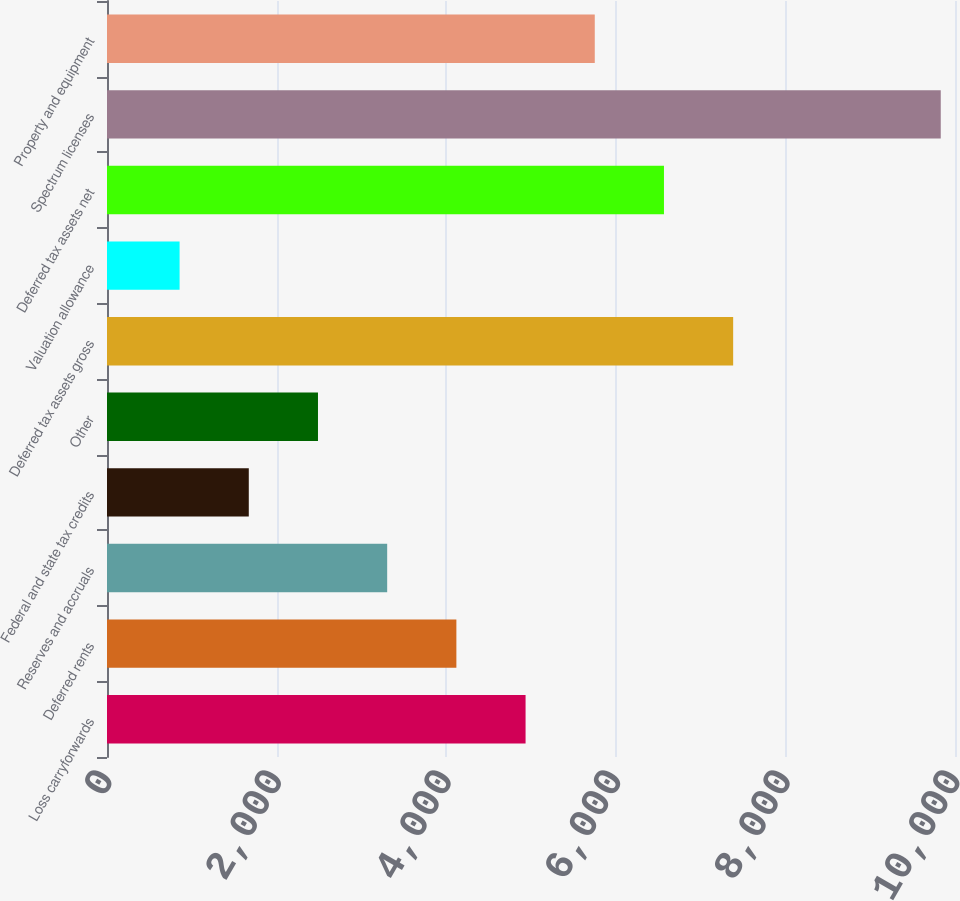<chart> <loc_0><loc_0><loc_500><loc_500><bar_chart><fcel>Loss carryforwards<fcel>Deferred rents<fcel>Reserves and accruals<fcel>Federal and state tax credits<fcel>Other<fcel>Deferred tax assets gross<fcel>Valuation allowance<fcel>Deferred tax assets net<fcel>Spectrum licenses<fcel>Property and equipment<nl><fcel>4936<fcel>4120<fcel>3304<fcel>1672<fcel>2488<fcel>7384<fcel>856<fcel>6568<fcel>9832<fcel>5752<nl></chart> 